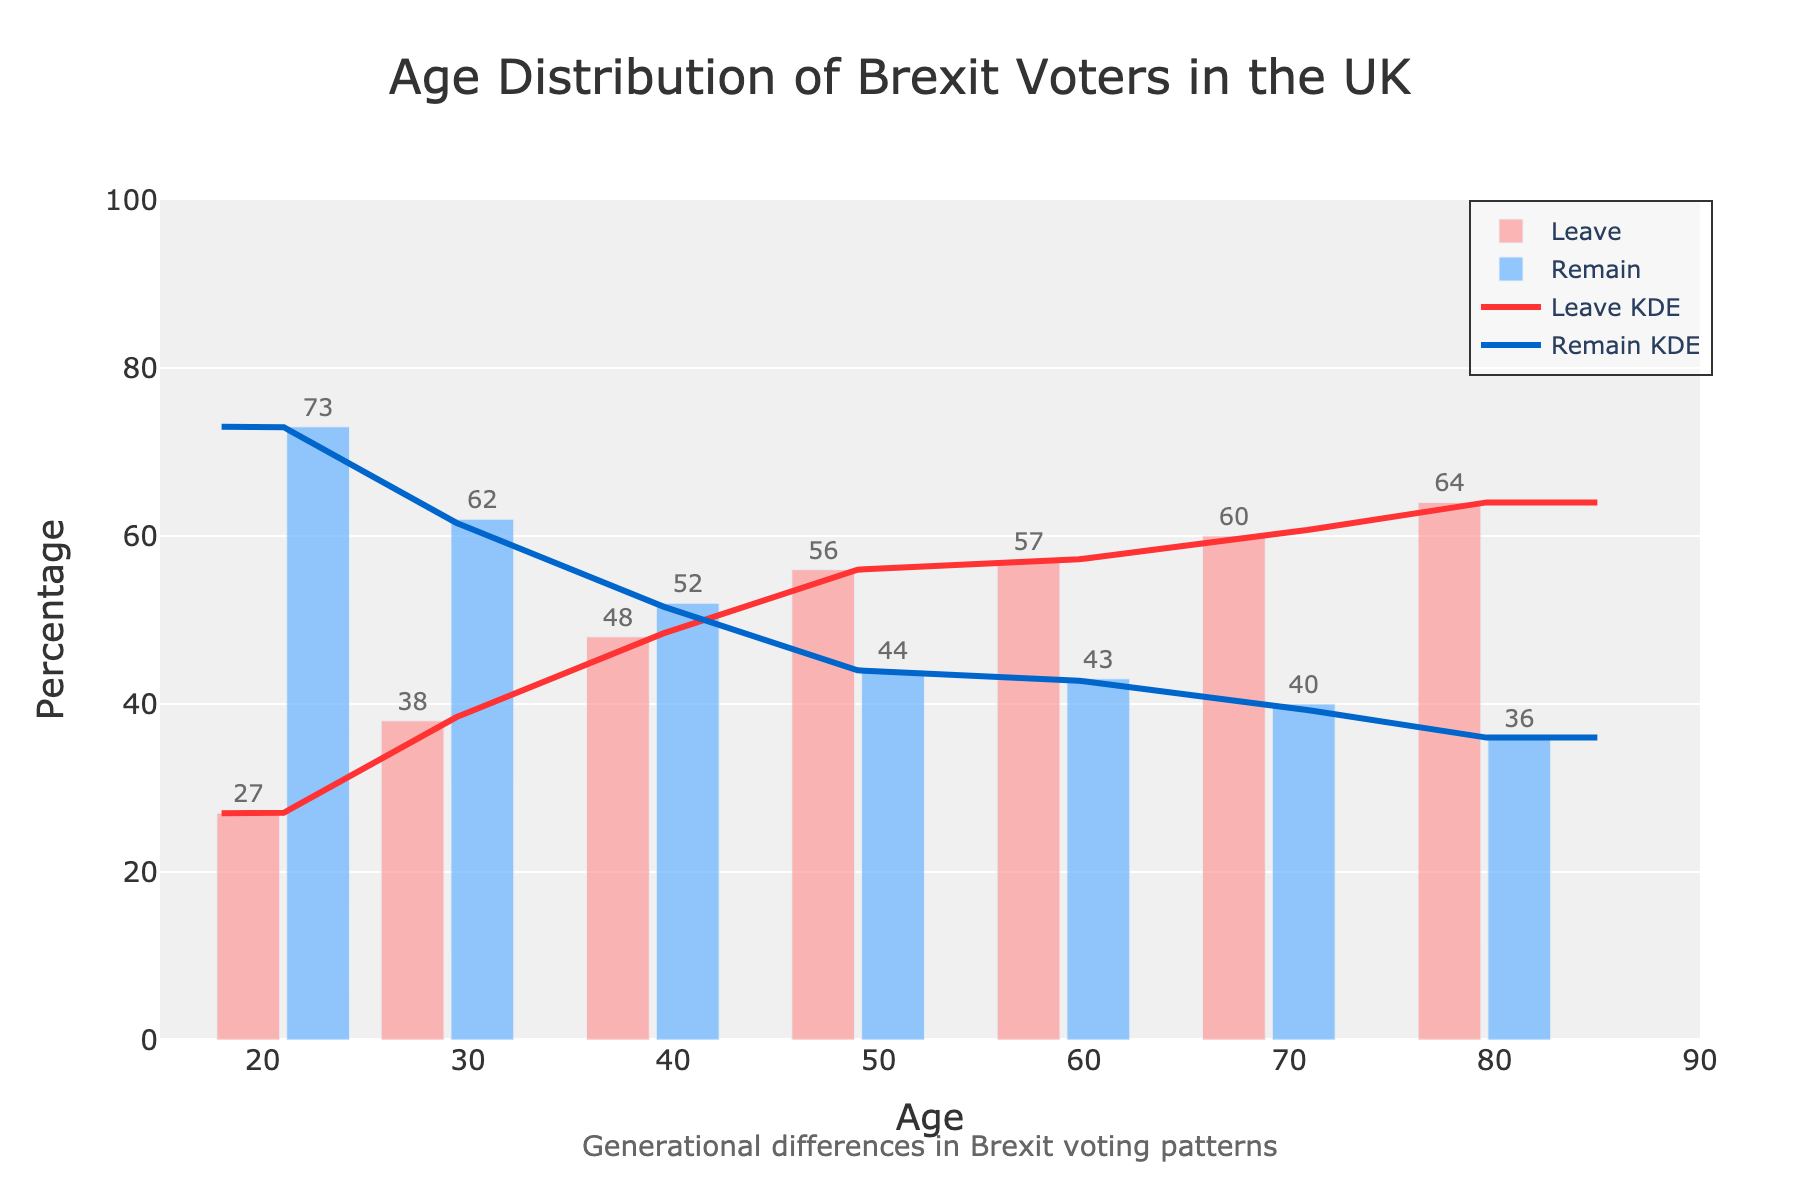What is the title of the figure? The title of the figure is prominently displayed at the top and usually gives an overview of what the graph is about. In this case, it indicates the subject of the analysis.
Answer: Age Distribution of Brexit Voters in the UK Which age group has the highest percentage of Leave voters? From the histogram, we can see that the age group with the highest bar in the Leave section is towards the older age bracket.
Answer: 75+ How does the KDE (density curve) for Leave voters change across age groups? The KDE (density curve) for Leave voters shows how the probability distribution of Leave voters changes across different ages. It increases steadily as the age group gets older, showing higher percentages in older generations.
Answer: It increases with age Which age group has a nearly balanced percentage between Leave and Remain voters? To find a nearly balanced percentage, we look for bars of roughly the same height in both Leave and Remain sections. This appears in the middle of the age spectrum.
Answer: 35-44 Compare the percentage of Remain voters in the 55-64 age group to the 25-34 age group. By examining the bars for the 55-64 and 25-34 age groups, the height difference indicates the difference in the percentage of Remain voters. The 25-34 age group has a higher percentage of Remain voters compared to the 55-64 age group.
Answer: 25-34 has higher Remain percentage At what ages do we see a crossover in the majority of Leave vs. Remain voters? The crossover is the point where Leave and Remain percentages are approximately equal. By observing the bars, we notice it around the middle age ranges, close to the 45-54 age group.
Answer: Around 45-54 What does the KDE curve tell you about younger voters (18-24)? The KDE curve for younger voters displays a lower density because the percentage of Leave voters is much smaller in this age group.
Answer: Lower density for Leave How do the oldest voters (75+) compare in Leave and Remain percentage? The histogram indicates a significantly higher Leave percentage compared to Remain for the 75+ age group, as the Leave bar is much taller.
Answer: Higher for Leave What overall trend do you observe in the Leave voters' percentages across age groups? By following the histogram bars from the youngest to the oldest age groups, there is a clear trend showing an increase in Leave voters' percentages as age increases.
Answer: Increasing with age How would you describe the voting pattern difference between the youngest and the oldest age groups? By comparing the bars for the youngest (18-24) and oldest (75+) age groups, there is a stark contrast where the youngest have a low percentage of Leave voters and a high percentage of Remain voters, whereas the oldest have the opposite pattern.
Answer: Young: low Leave, high Remain; Old: high Leave, low Remain 